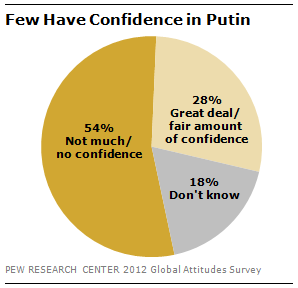Draw attention to some important aspects in this diagram. The difference in the value of the smallest two segments of the graph is 10. The color of the biggest segment of the graph is orange. 